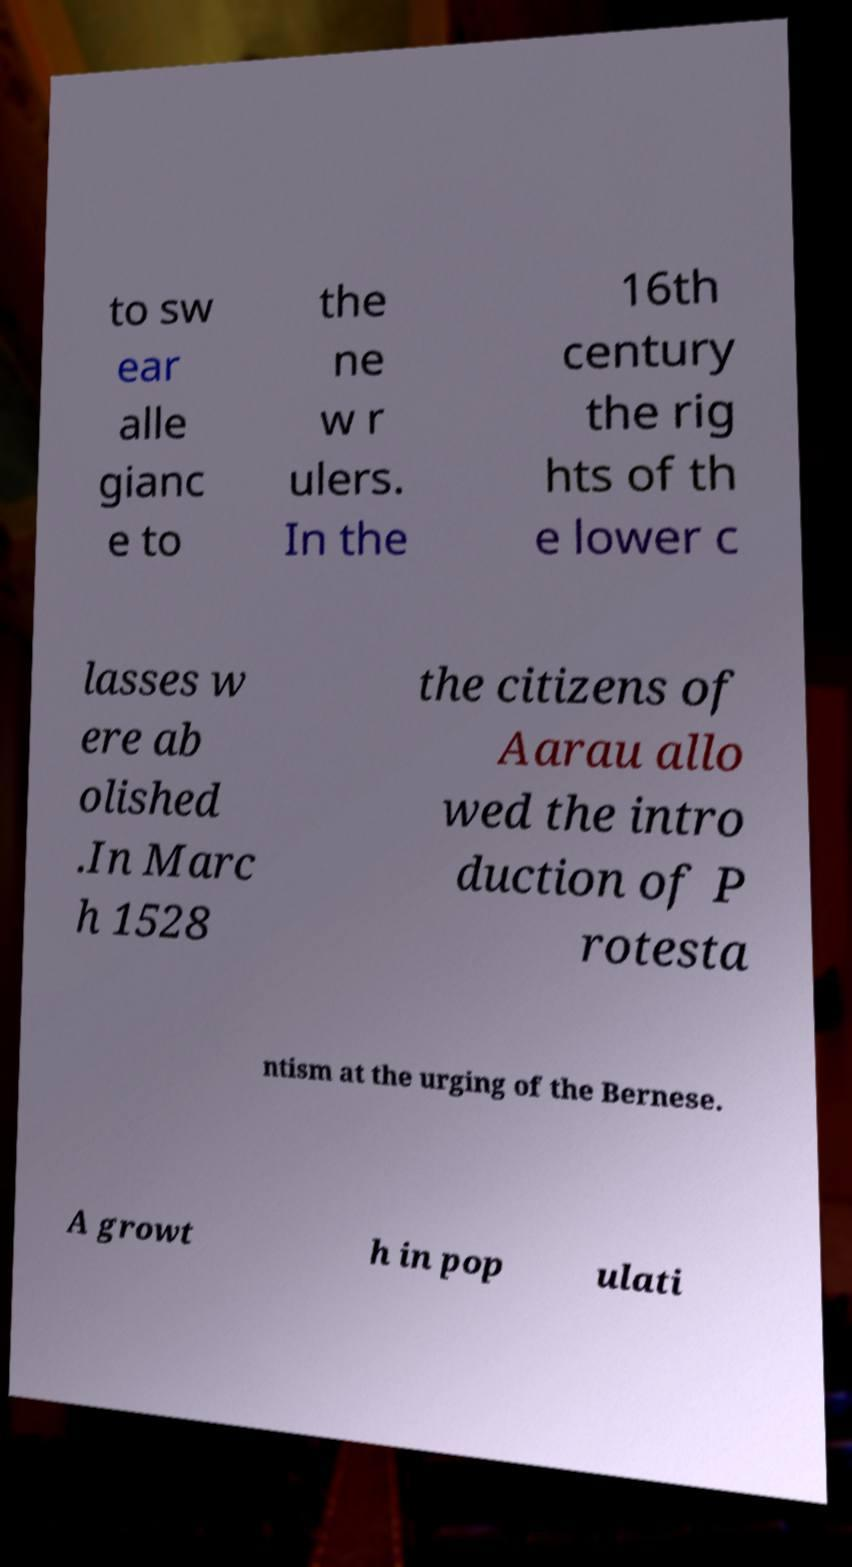Can you accurately transcribe the text from the provided image for me? to sw ear alle gianc e to the ne w r ulers. In the 16th century the rig hts of th e lower c lasses w ere ab olished .In Marc h 1528 the citizens of Aarau allo wed the intro duction of P rotesta ntism at the urging of the Bernese. A growt h in pop ulati 